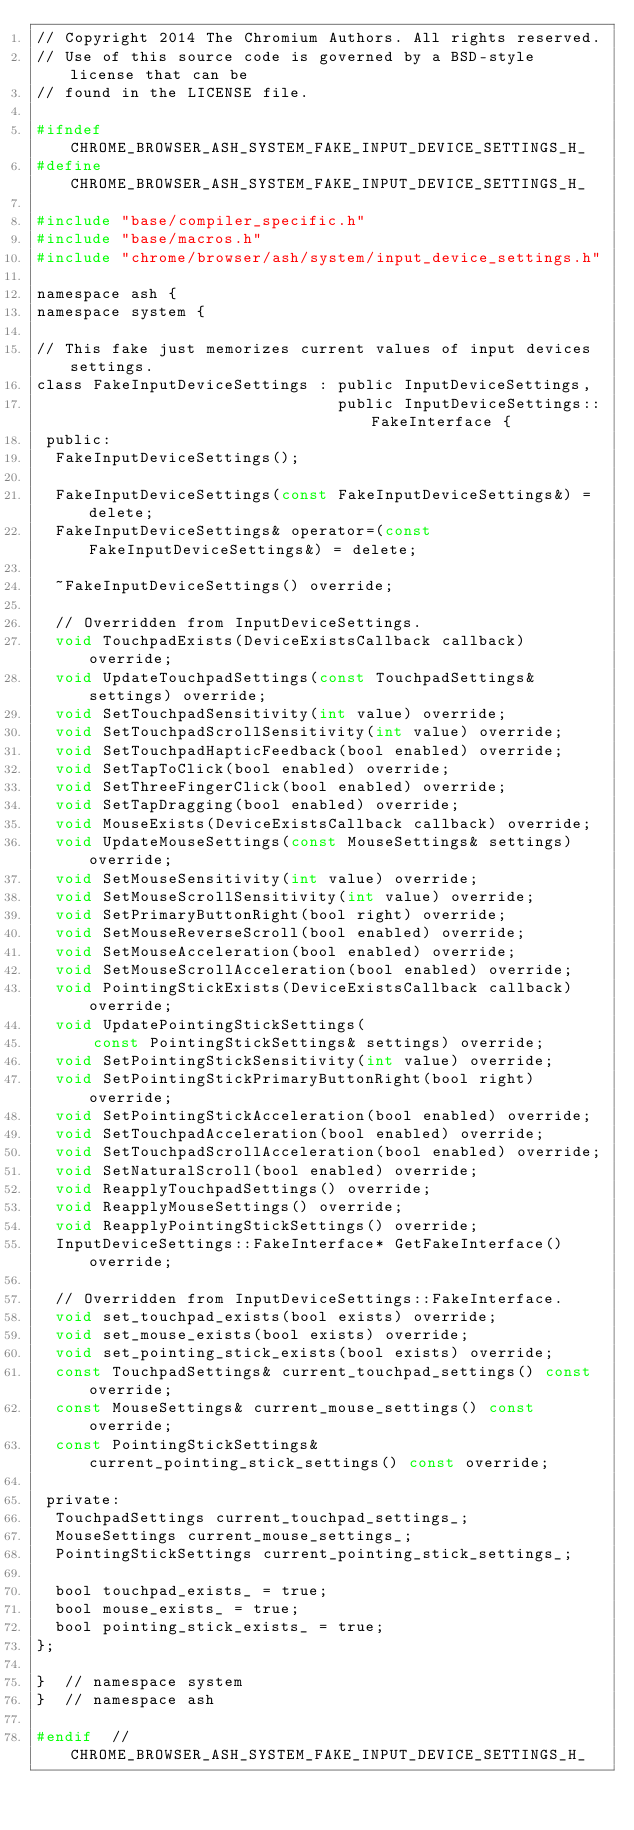<code> <loc_0><loc_0><loc_500><loc_500><_C_>// Copyright 2014 The Chromium Authors. All rights reserved.
// Use of this source code is governed by a BSD-style license that can be
// found in the LICENSE file.

#ifndef CHROME_BROWSER_ASH_SYSTEM_FAKE_INPUT_DEVICE_SETTINGS_H_
#define CHROME_BROWSER_ASH_SYSTEM_FAKE_INPUT_DEVICE_SETTINGS_H_

#include "base/compiler_specific.h"
#include "base/macros.h"
#include "chrome/browser/ash/system/input_device_settings.h"

namespace ash {
namespace system {

// This fake just memorizes current values of input devices settings.
class FakeInputDeviceSettings : public InputDeviceSettings,
                                public InputDeviceSettings::FakeInterface {
 public:
  FakeInputDeviceSettings();

  FakeInputDeviceSettings(const FakeInputDeviceSettings&) = delete;
  FakeInputDeviceSettings& operator=(const FakeInputDeviceSettings&) = delete;

  ~FakeInputDeviceSettings() override;

  // Overridden from InputDeviceSettings.
  void TouchpadExists(DeviceExistsCallback callback) override;
  void UpdateTouchpadSettings(const TouchpadSettings& settings) override;
  void SetTouchpadSensitivity(int value) override;
  void SetTouchpadScrollSensitivity(int value) override;
  void SetTouchpadHapticFeedback(bool enabled) override;
  void SetTapToClick(bool enabled) override;
  void SetThreeFingerClick(bool enabled) override;
  void SetTapDragging(bool enabled) override;
  void MouseExists(DeviceExistsCallback callback) override;
  void UpdateMouseSettings(const MouseSettings& settings) override;
  void SetMouseSensitivity(int value) override;
  void SetMouseScrollSensitivity(int value) override;
  void SetPrimaryButtonRight(bool right) override;
  void SetMouseReverseScroll(bool enabled) override;
  void SetMouseAcceleration(bool enabled) override;
  void SetMouseScrollAcceleration(bool enabled) override;
  void PointingStickExists(DeviceExistsCallback callback) override;
  void UpdatePointingStickSettings(
      const PointingStickSettings& settings) override;
  void SetPointingStickSensitivity(int value) override;
  void SetPointingStickPrimaryButtonRight(bool right) override;
  void SetPointingStickAcceleration(bool enabled) override;
  void SetTouchpadAcceleration(bool enabled) override;
  void SetTouchpadScrollAcceleration(bool enabled) override;
  void SetNaturalScroll(bool enabled) override;
  void ReapplyTouchpadSettings() override;
  void ReapplyMouseSettings() override;
  void ReapplyPointingStickSettings() override;
  InputDeviceSettings::FakeInterface* GetFakeInterface() override;

  // Overridden from InputDeviceSettings::FakeInterface.
  void set_touchpad_exists(bool exists) override;
  void set_mouse_exists(bool exists) override;
  void set_pointing_stick_exists(bool exists) override;
  const TouchpadSettings& current_touchpad_settings() const override;
  const MouseSettings& current_mouse_settings() const override;
  const PointingStickSettings& current_pointing_stick_settings() const override;

 private:
  TouchpadSettings current_touchpad_settings_;
  MouseSettings current_mouse_settings_;
  PointingStickSettings current_pointing_stick_settings_;

  bool touchpad_exists_ = true;
  bool mouse_exists_ = true;
  bool pointing_stick_exists_ = true;
};

}  // namespace system
}  // namespace ash

#endif  // CHROME_BROWSER_ASH_SYSTEM_FAKE_INPUT_DEVICE_SETTINGS_H_
</code> 